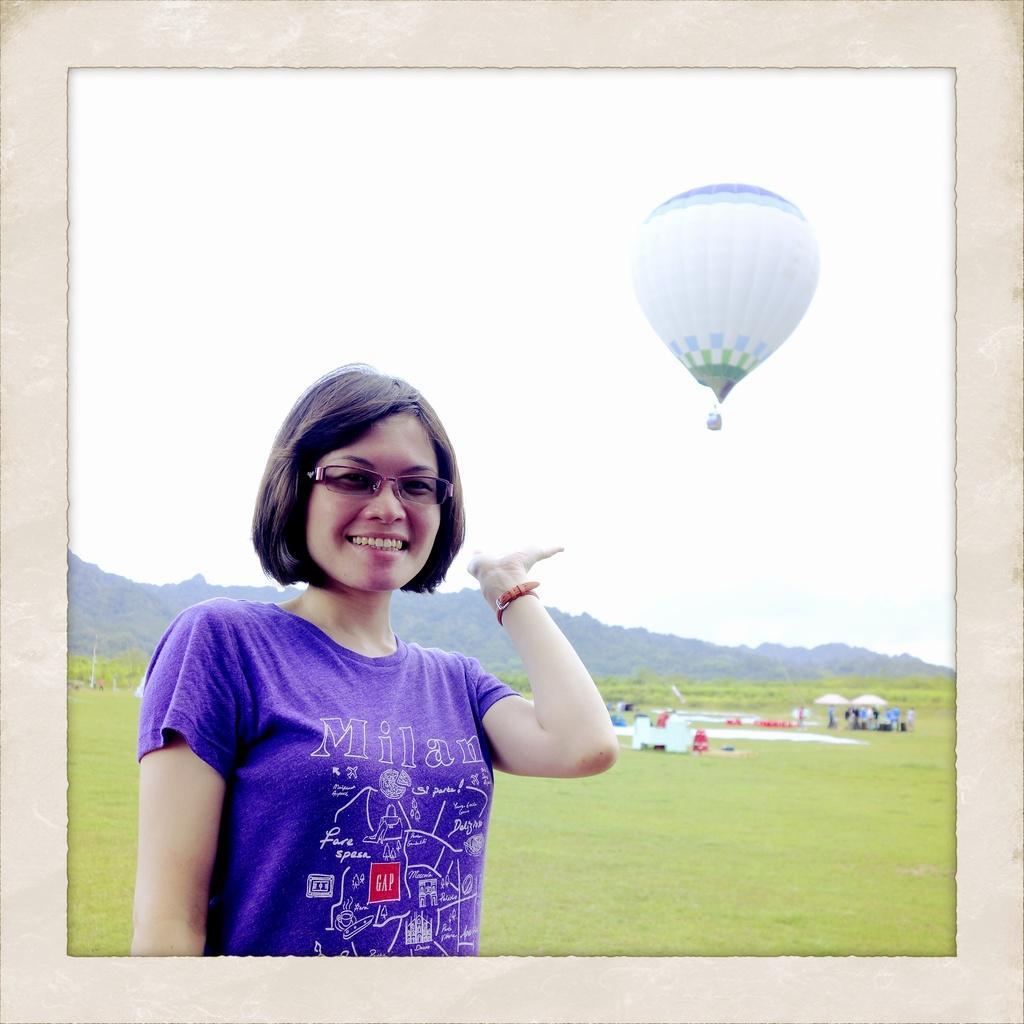Could you give a brief overview of what you see in this image? In this image I can see a man is standing and smiling. The woman is wearing glasses and a purple color t-shirt. In the background I can see a parachute, mountains, the sky and some other objects on the ground. 